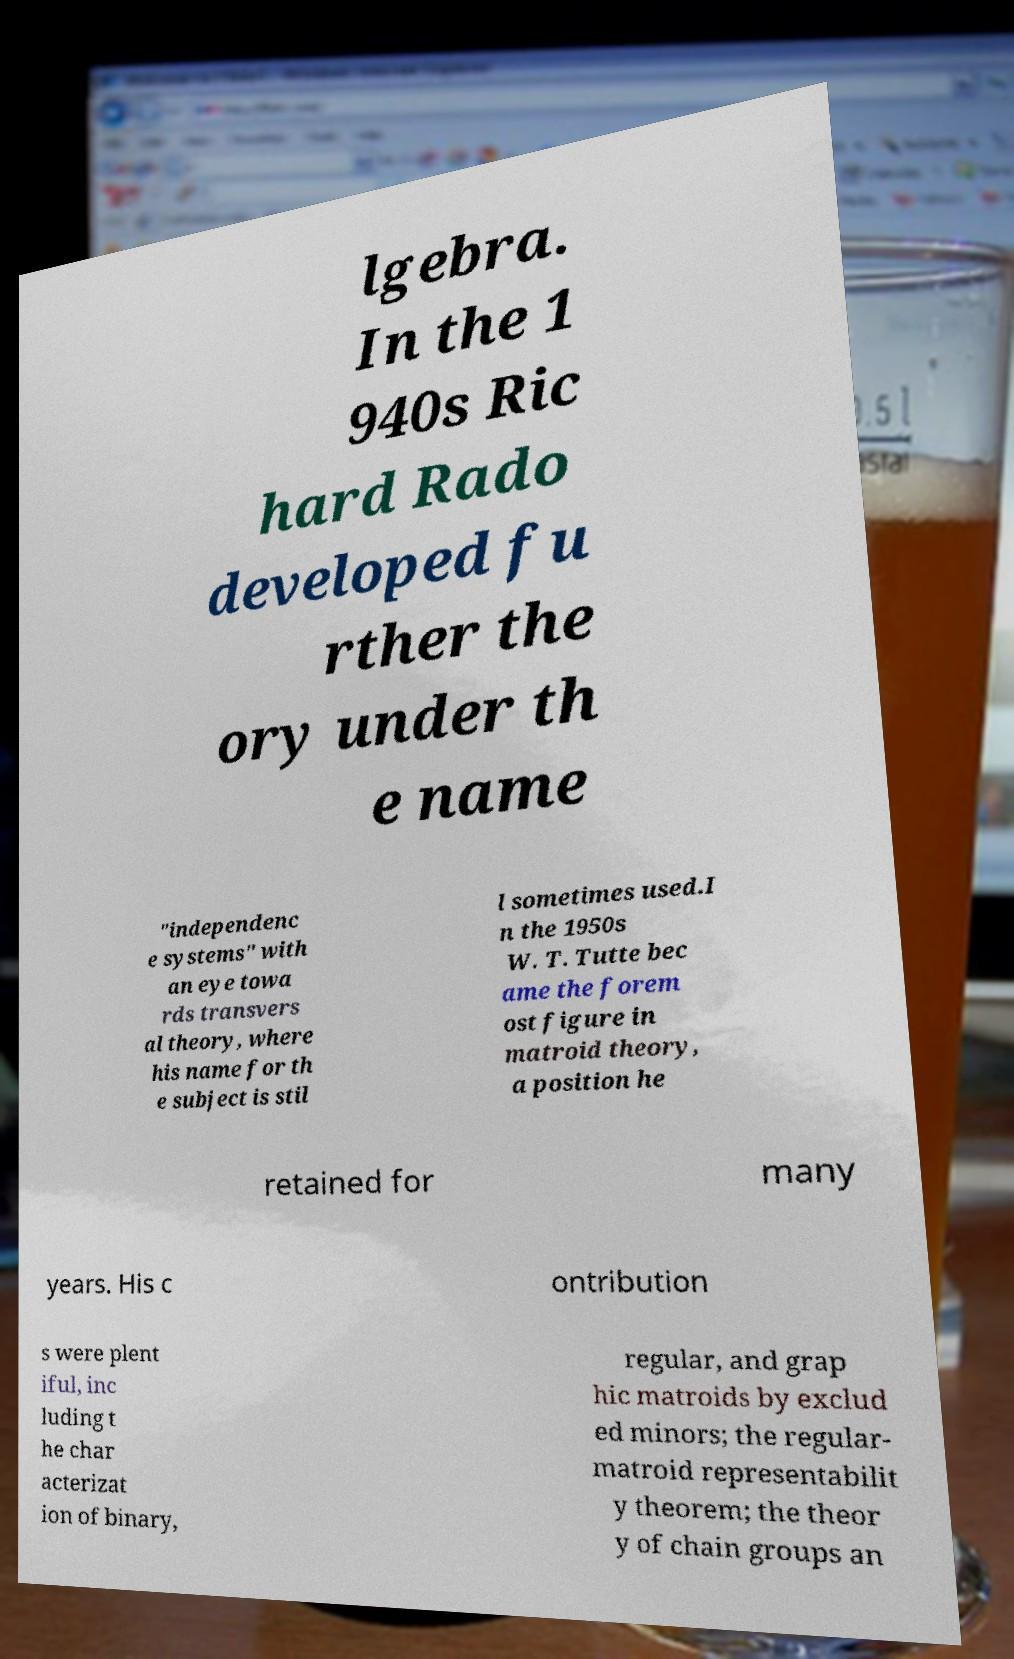Can you read and provide the text displayed in the image?This photo seems to have some interesting text. Can you extract and type it out for me? lgebra. In the 1 940s Ric hard Rado developed fu rther the ory under th e name "independenc e systems" with an eye towa rds transvers al theory, where his name for th e subject is stil l sometimes used.I n the 1950s W. T. Tutte bec ame the forem ost figure in matroid theory, a position he retained for many years. His c ontribution s were plent iful, inc luding t he char acterizat ion of binary, regular, and grap hic matroids by exclud ed minors; the regular- matroid representabilit y theorem; the theor y of chain groups an 